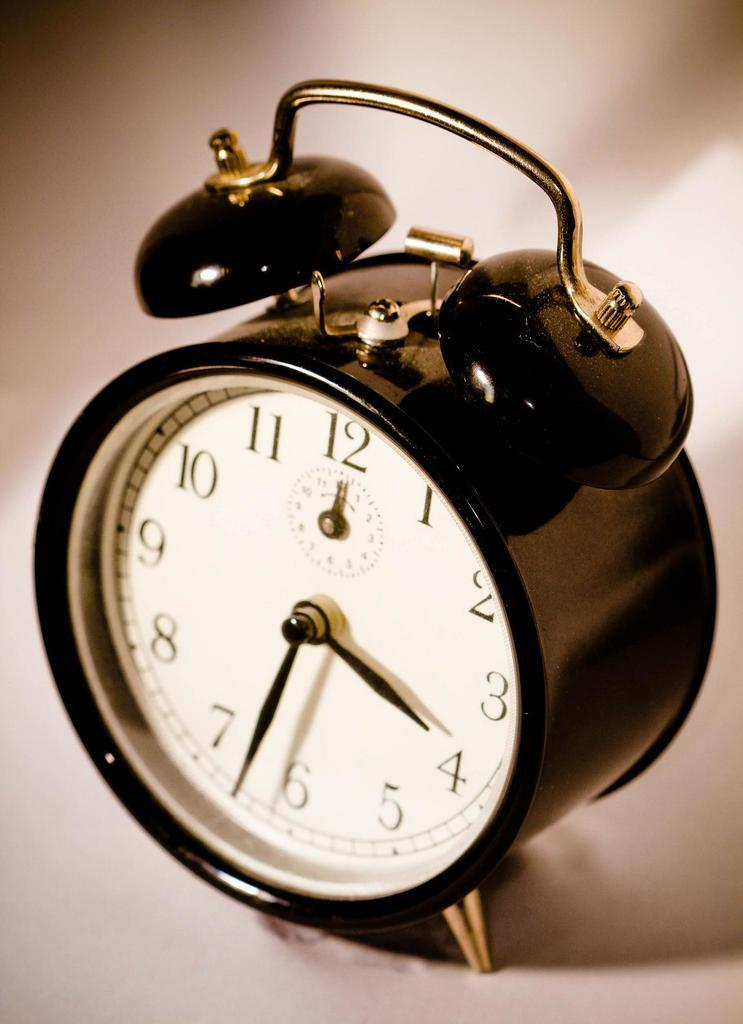<image>
Give a short and clear explanation of the subsequent image. Vintage alarm clock showing the time at 3:30 and is colored black and white. 